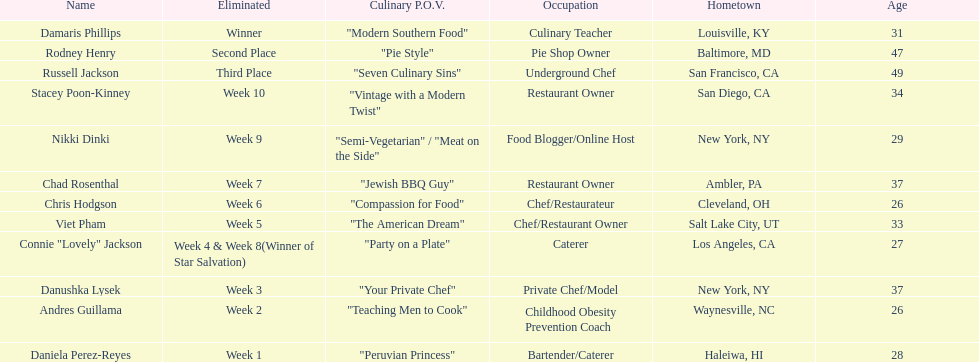Who was eliminated first, nikki dinki or viet pham? Viet Pham. 